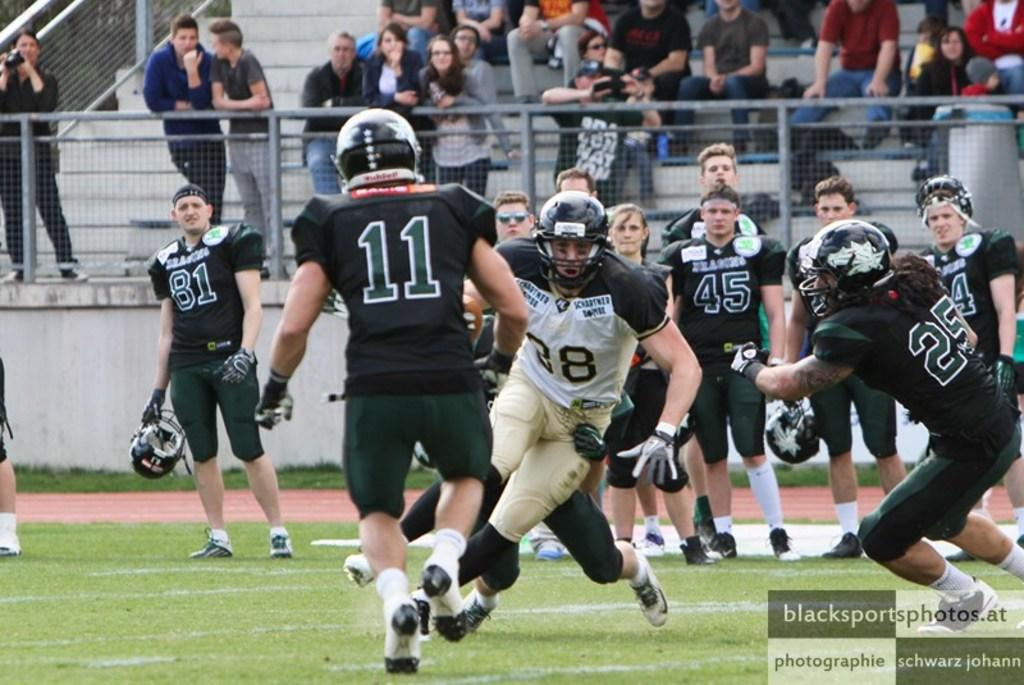What is happening on the ground in the image? There are people on the ground in the image. What can be seen in the background of the image? There is a group of people, a fence, and steps in the background of the image. Where is the text located in the image? The text is in the bottom right corner of the image. What type of event is being advertised in the image? There is no event being advertised in the image; there is just text in the bottom right corner. How does the image express hate towards a particular group of people? The image does not express hate towards any group of people; it simply shows people on the ground and in the background. 